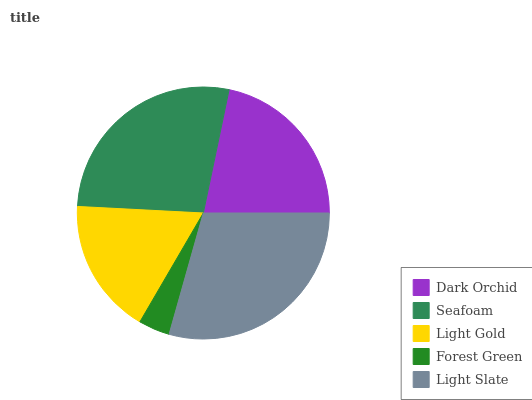Is Forest Green the minimum?
Answer yes or no. Yes. Is Light Slate the maximum?
Answer yes or no. Yes. Is Seafoam the minimum?
Answer yes or no. No. Is Seafoam the maximum?
Answer yes or no. No. Is Seafoam greater than Dark Orchid?
Answer yes or no. Yes. Is Dark Orchid less than Seafoam?
Answer yes or no. Yes. Is Dark Orchid greater than Seafoam?
Answer yes or no. No. Is Seafoam less than Dark Orchid?
Answer yes or no. No. Is Dark Orchid the high median?
Answer yes or no. Yes. Is Dark Orchid the low median?
Answer yes or no. Yes. Is Light Slate the high median?
Answer yes or no. No. Is Light Gold the low median?
Answer yes or no. No. 